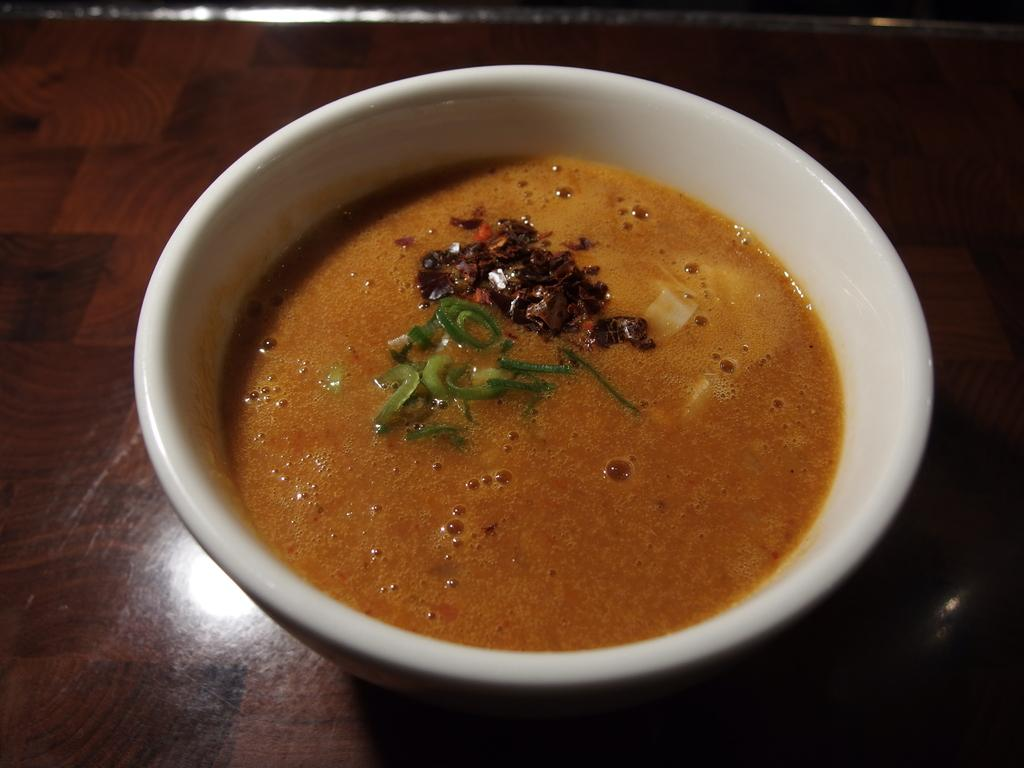What is in the bowl that is visible in the image? The bowl contains food items. Where is the bowl located in the image? The bowl is placed on a table. Can you describe the contents of the bowl in more detail? Unfortunately, the specific food items in the bowl cannot be determined from the provided facts. What type of hair can be seen on the food items in the image? There is no hair present on the food items in the image, as the provided facts do not mention any hair or hair-like substances. 